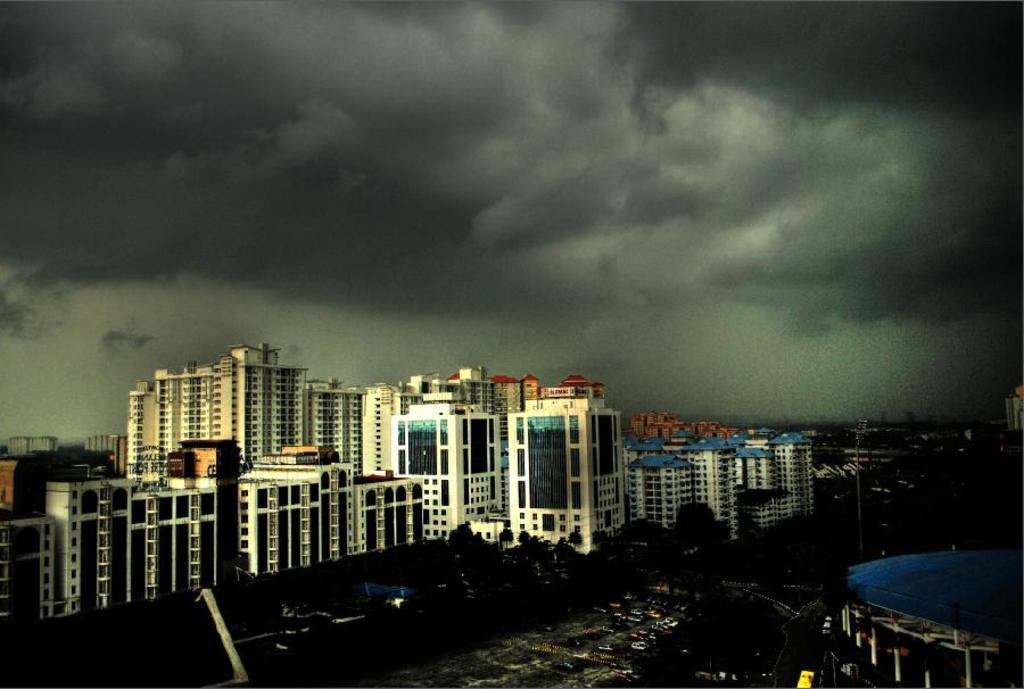What type of structures can be seen in the image? There are buildings in the image. What other natural elements are present in the image? There are trees in the image. What man-made objects can be seen in the image? There are vehicles and poles in the image. Are there any other objects on the ground in the image? Yes, there are other objects on the ground in the image. What can be seen in the background of the image? The sky is visible in the background of the image. How would you describe the lighting in the image? The image is slightly dark. How many women are serving the team in the image? There are no women or teams present in the image. What type of servant is attending to the needs of the women in the image? There are no servants or women present in the image. 